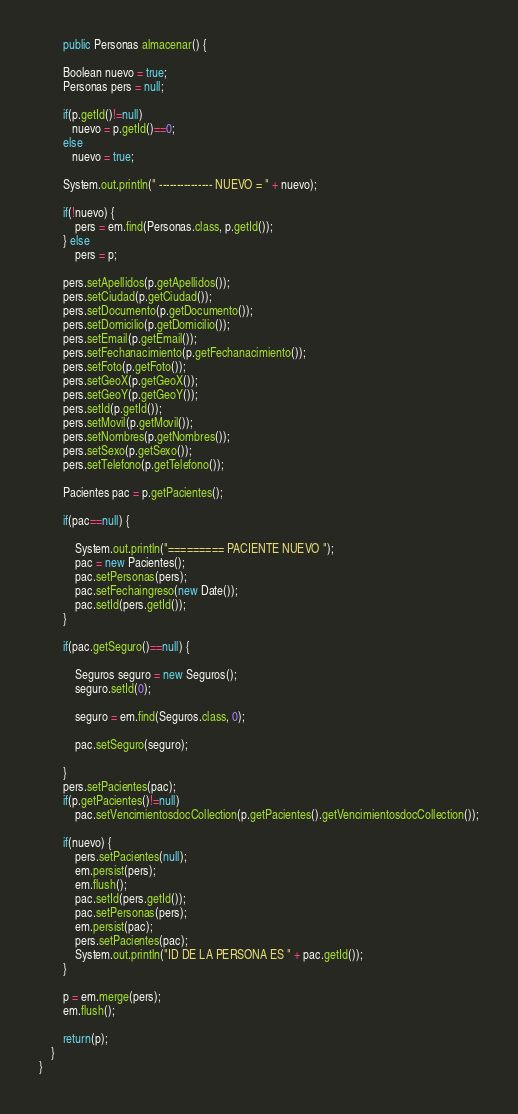<code> <loc_0><loc_0><loc_500><loc_500><_Java_>
        public Personas almacenar() {

        Boolean nuevo = true;
        Personas pers = null;

        if(p.getId()!=null)
           nuevo = p.getId()==0;
        else
           nuevo = true;

        System.out.println(" --------------- NUEVO = " + nuevo);
        
        if(!nuevo) {
            pers = em.find(Personas.class, p.getId());
        } else
            pers = p;

        pers.setApellidos(p.getApellidos());
        pers.setCiudad(p.getCiudad());
        pers.setDocumento(p.getDocumento());
        pers.setDomicilio(p.getDomicilio());
        pers.setEmail(p.getEmail());
        pers.setFechanacimiento(p.getFechanacimiento());
        pers.setFoto(p.getFoto());
        pers.setGeoX(p.getGeoX());
        pers.setGeoY(p.getGeoY());
        pers.setId(p.getId());
        pers.setMovil(p.getMovil());
        pers.setNombres(p.getNombres());
        pers.setSexo(p.getSexo());
        pers.setTelefono(p.getTelefono());

        Pacientes pac = p.getPacientes();

        if(pac==null) {

            System.out.println("========= PACIENTE NUEVO ");
            pac = new Pacientes();
            pac.setPersonas(pers);
            pac.setFechaingreso(new Date());
            pac.setId(pers.getId());
        }

        if(pac.getSeguro()==null) {

            Seguros seguro = new Seguros();
            seguro.setId(0);

            seguro = em.find(Seguros.class, 0);

            pac.setSeguro(seguro);

        }
        pers.setPacientes(pac);
        if(p.getPacientes()!=null)
            pac.setVencimientosdocCollection(p.getPacientes().getVencimientosdocCollection());

        if(nuevo) {
            pers.setPacientes(null);
            em.persist(pers);
            em.flush();
            pac.setId(pers.getId());
            pac.setPersonas(pers);
            em.persist(pac);
            pers.setPacientes(pac);
            System.out.println("ID DE LA PERSONA ES " + pac.getId());
        }

        p = em.merge(pers);
        em.flush();

        return(p);
    }
}
</code> 